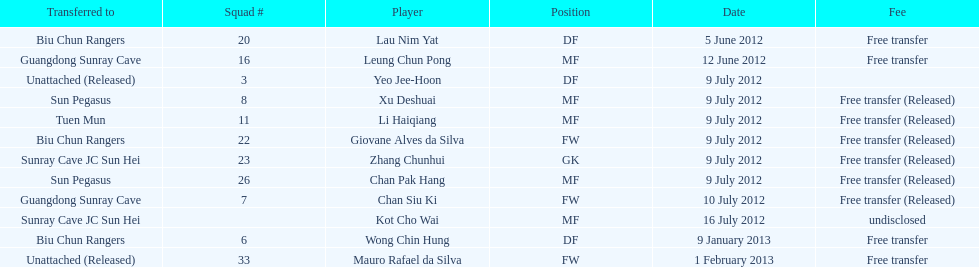Which team did lau nim yat play for after he was transferred? Biu Chun Rangers. 